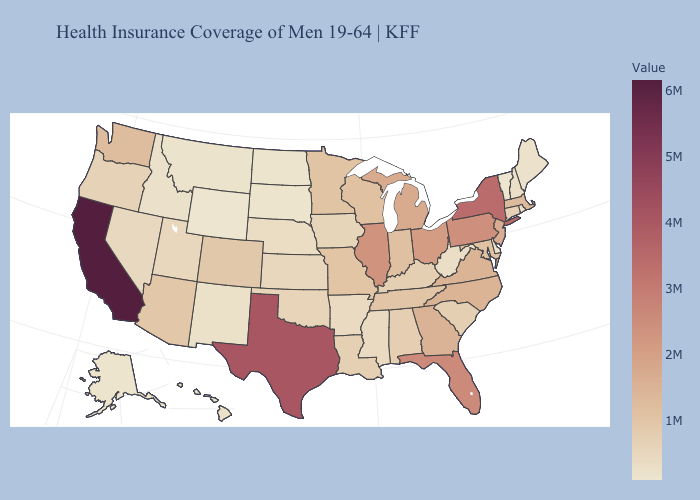Does the map have missing data?
Give a very brief answer. No. Does Oregon have the highest value in the USA?
Be succinct. No. Is the legend a continuous bar?
Be succinct. Yes. Does Pennsylvania have the lowest value in the Northeast?
Be succinct. No. Which states have the lowest value in the USA?
Keep it brief. Vermont. 